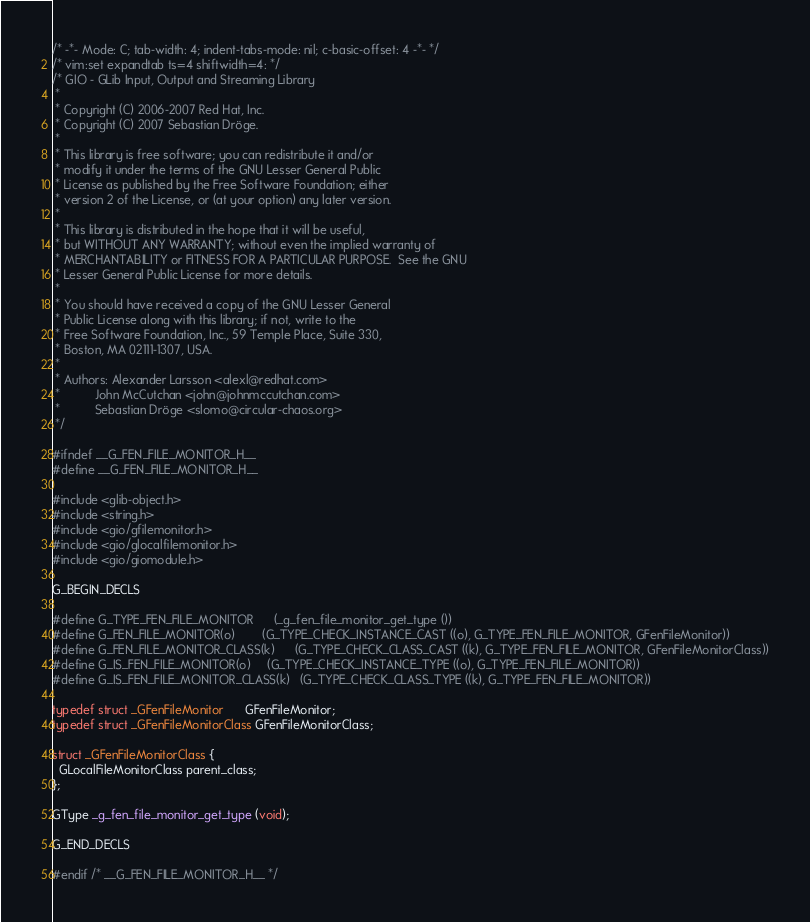<code> <loc_0><loc_0><loc_500><loc_500><_C_>/* -*- Mode: C; tab-width: 4; indent-tabs-mode: nil; c-basic-offset: 4 -*- */
/* vim:set expandtab ts=4 shiftwidth=4: */
/* GIO - GLib Input, Output and Streaming Library
 * 
 * Copyright (C) 2006-2007 Red Hat, Inc.
 * Copyright (C) 2007 Sebastian Dröge.
 *
 * This library is free software; you can redistribute it and/or
 * modify it under the terms of the GNU Lesser General Public
 * License as published by the Free Software Foundation; either
 * version 2 of the License, or (at your option) any later version.
 *
 * This library is distributed in the hope that it will be useful,
 * but WITHOUT ANY WARRANTY; without even the implied warranty of
 * MERCHANTABILITY or FITNESS FOR A PARTICULAR PURPOSE.  See the GNU
 * Lesser General Public License for more details.
 *
 * You should have received a copy of the GNU Lesser General
 * Public License along with this library; if not, write to the
 * Free Software Foundation, Inc., 59 Temple Place, Suite 330,
 * Boston, MA 02111-1307, USA.
 *
 * Authors: Alexander Larsson <alexl@redhat.com>
 *          John McCutchan <john@johnmccutchan.com> 
 *          Sebastian Dröge <slomo@circular-chaos.org>
 */

#ifndef __G_FEN_FILE_MONITOR_H__
#define __G_FEN_FILE_MONITOR_H__

#include <glib-object.h>
#include <string.h>
#include <gio/gfilemonitor.h>
#include <gio/glocalfilemonitor.h>
#include <gio/giomodule.h>

G_BEGIN_DECLS

#define G_TYPE_FEN_FILE_MONITOR		(_g_fen_file_monitor_get_type ())
#define G_FEN_FILE_MONITOR(o)		(G_TYPE_CHECK_INSTANCE_CAST ((o), G_TYPE_FEN_FILE_MONITOR, GFenFileMonitor))
#define G_FEN_FILE_MONITOR_CLASS(k)		(G_TYPE_CHECK_CLASS_CAST ((k), G_TYPE_FEN_FILE_MONITOR, GFenFileMonitorClass))
#define G_IS_FEN_FILE_MONITOR(o)		(G_TYPE_CHECK_INSTANCE_TYPE ((o), G_TYPE_FEN_FILE_MONITOR))
#define G_IS_FEN_FILE_MONITOR_CLASS(k)	(G_TYPE_CHECK_CLASS_TYPE ((k), G_TYPE_FEN_FILE_MONITOR))

typedef struct _GFenFileMonitor      GFenFileMonitor;
typedef struct _GFenFileMonitorClass GFenFileMonitorClass;

struct _GFenFileMonitorClass {
  GLocalFileMonitorClass parent_class;
};

GType _g_fen_file_monitor_get_type (void);

G_END_DECLS

#endif /* __G_FEN_FILE_MONITOR_H__ */
</code> 